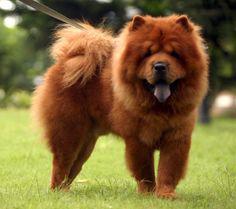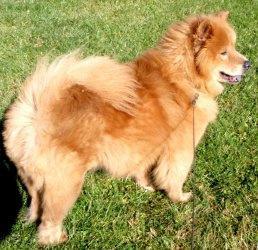The first image is the image on the left, the second image is the image on the right. For the images displayed, is the sentence "In at least one image there is a tan fluffy dog sitting in the grass" factually correct? Answer yes or no. No. The first image is the image on the left, the second image is the image on the right. Assess this claim about the two images: "There are only two dogs total and none are laying down.". Correct or not? Answer yes or no. Yes. 